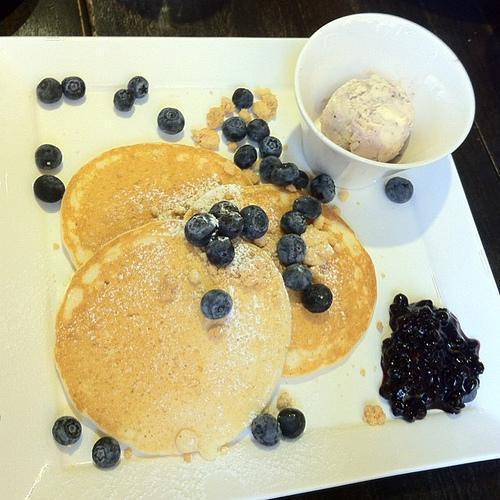How many pancakes are visible?
Give a very brief answer. 3. 